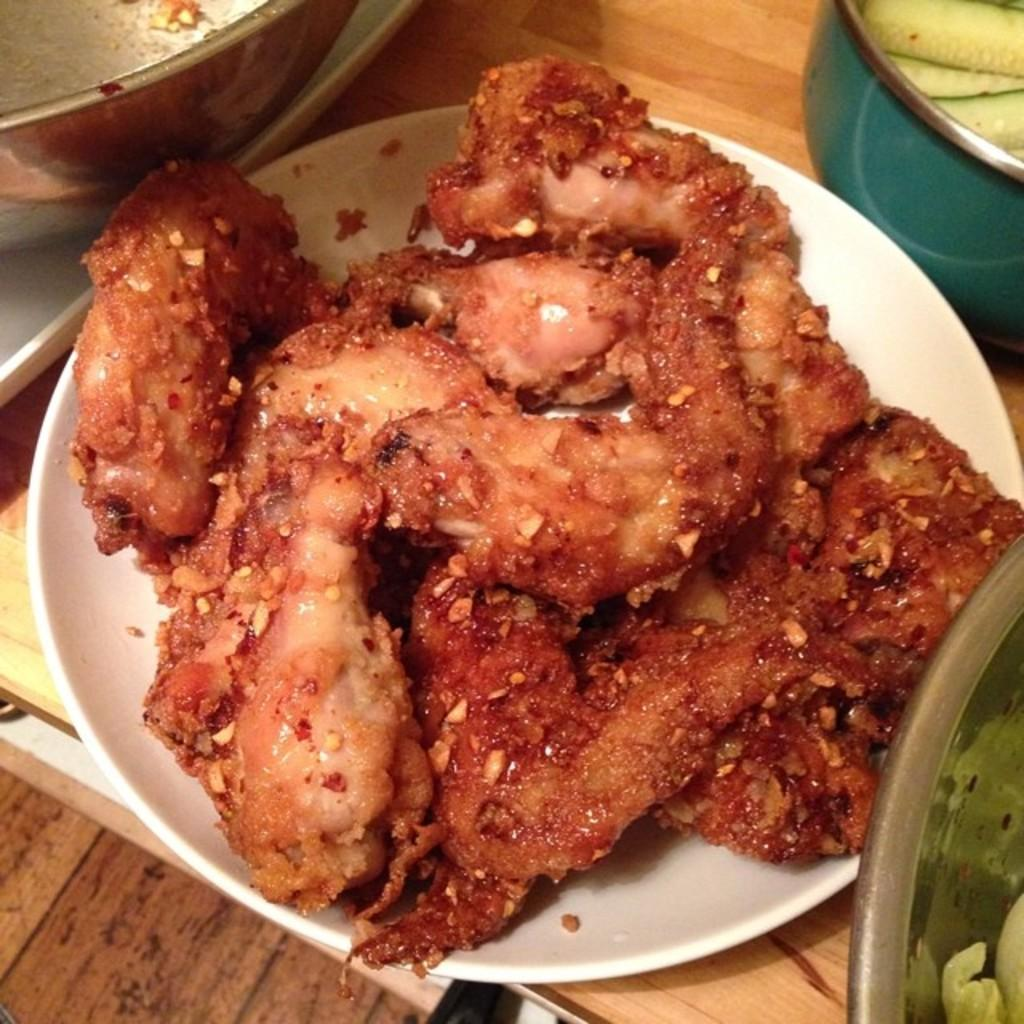What is the main food item visible in the image? There is a food item in a plate in the image. What type of tableware is present on the table in the image? There are bowls on the table in the image. What else can be seen on the table in the image besides the food item and bowls? There are other unspecified items on the table in the image. What type of observation is being conducted in the image? There is no indication of an observation being conducted in the image. What type of operation is being performed in the image? There is no operation or procedure being depicted in the image. 